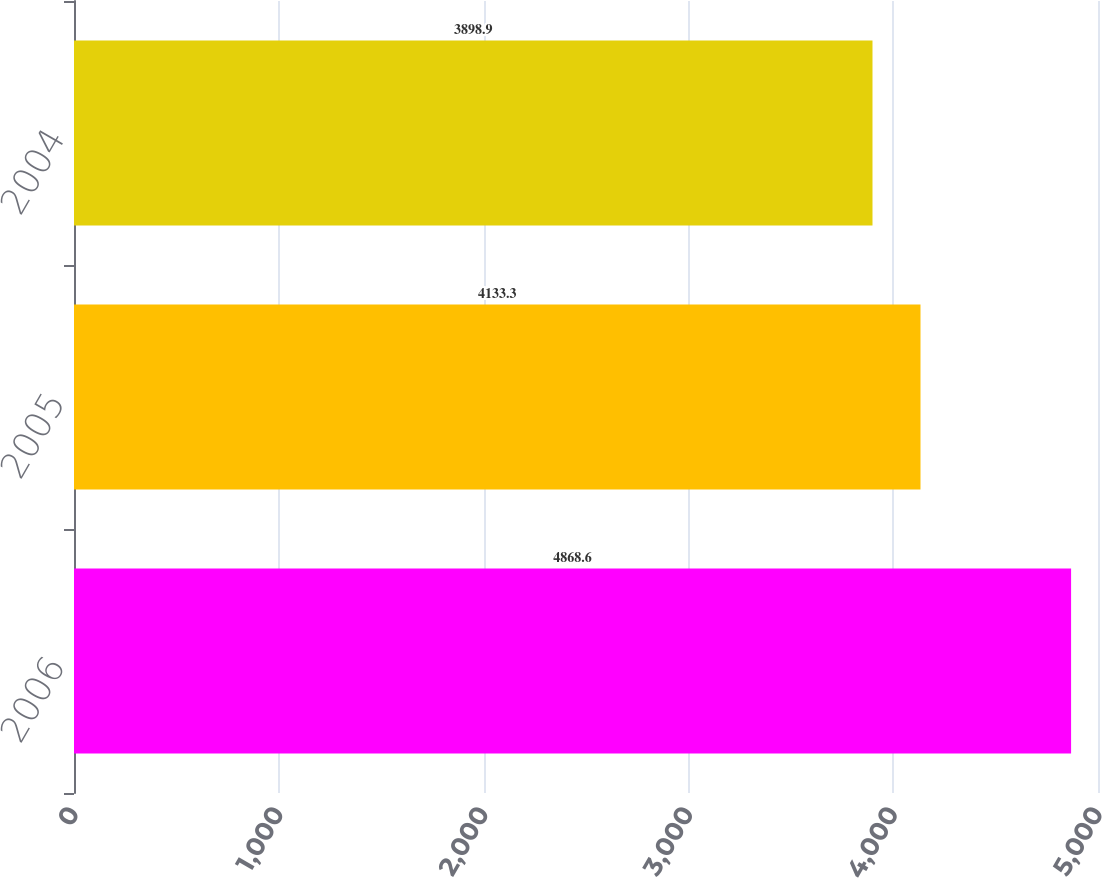<chart> <loc_0><loc_0><loc_500><loc_500><bar_chart><fcel>2006<fcel>2005<fcel>2004<nl><fcel>4868.6<fcel>4133.3<fcel>3898.9<nl></chart> 